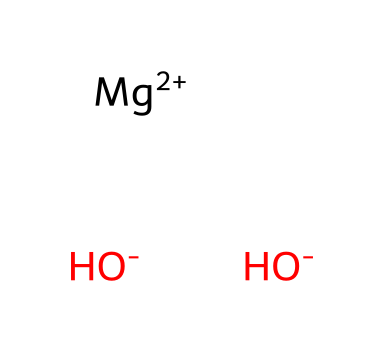What is the name of this chemical? The SMILES representation indicates the presence of magnesium and hydroxide ions. Together, these form magnesium hydroxide, which is recognized widely as an antacid.
Answer: magnesium hydroxide How many hydroxide ions are present in this chemical? The SMILES structure shows two hydroxide ions denoted by [OH-]. Thus, the number of hydroxide ions can be counted directly from the representation.
Answer: two What is the oxidation state of magnesium in this compound? In the SMILES string, magnesium is represented as [Mg+2]. The +2 indicates that magnesium has lost two electrons, confirming its oxidation state is +2.
Answer: +2 What type of base is magnesium hydroxide? Magnesium hydroxide is classified as a neutralizing base because it reacts with acids to form salt and water, typically used in medical applications for heartburn relief.
Answer: neutralizing base What is the total number of atoms in this chemical? The structure contains one magnesium atom and two oxygen atoms from the hydroxide ions, plus two hydrogen atoms (one from each hydroxide). Adding these gives a total of five atoms.
Answer: five Why is magnesium hydroxide used in antacids? Magnesium hydroxide neutralizes stomach acid due to the presence of hydroxide ions, which react with H+ ions from the acid to form water. This reaction provides relief from heartburn.
Answer: neutralizes stomach acid 